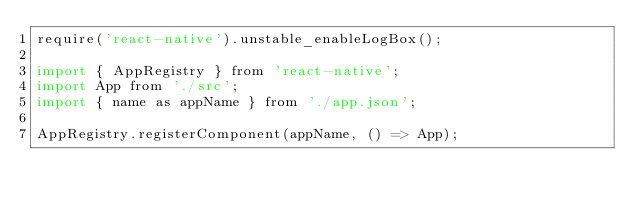<code> <loc_0><loc_0><loc_500><loc_500><_JavaScript_>require('react-native').unstable_enableLogBox();

import { AppRegistry } from 'react-native';
import App from './src';
import { name as appName } from './app.json';

AppRegistry.registerComponent(appName, () => App);
</code> 